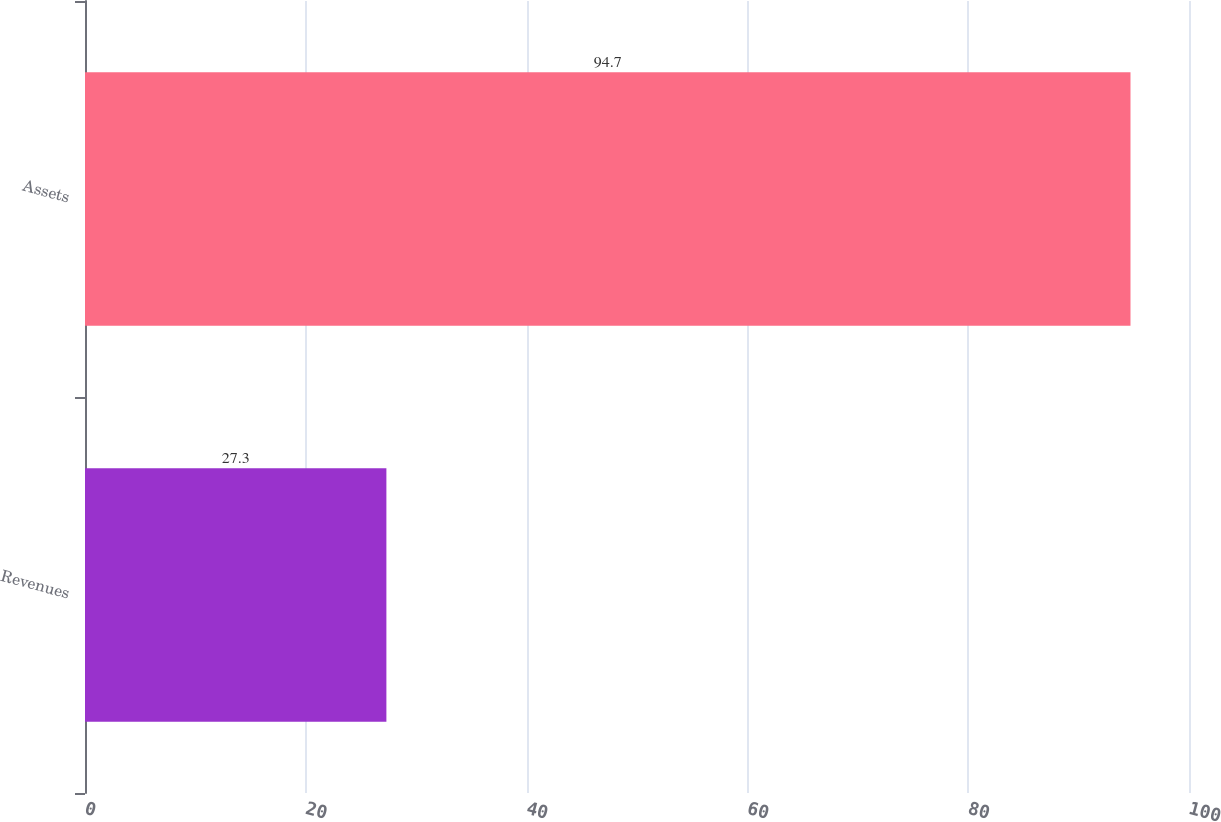<chart> <loc_0><loc_0><loc_500><loc_500><bar_chart><fcel>Revenues<fcel>Assets<nl><fcel>27.3<fcel>94.7<nl></chart> 